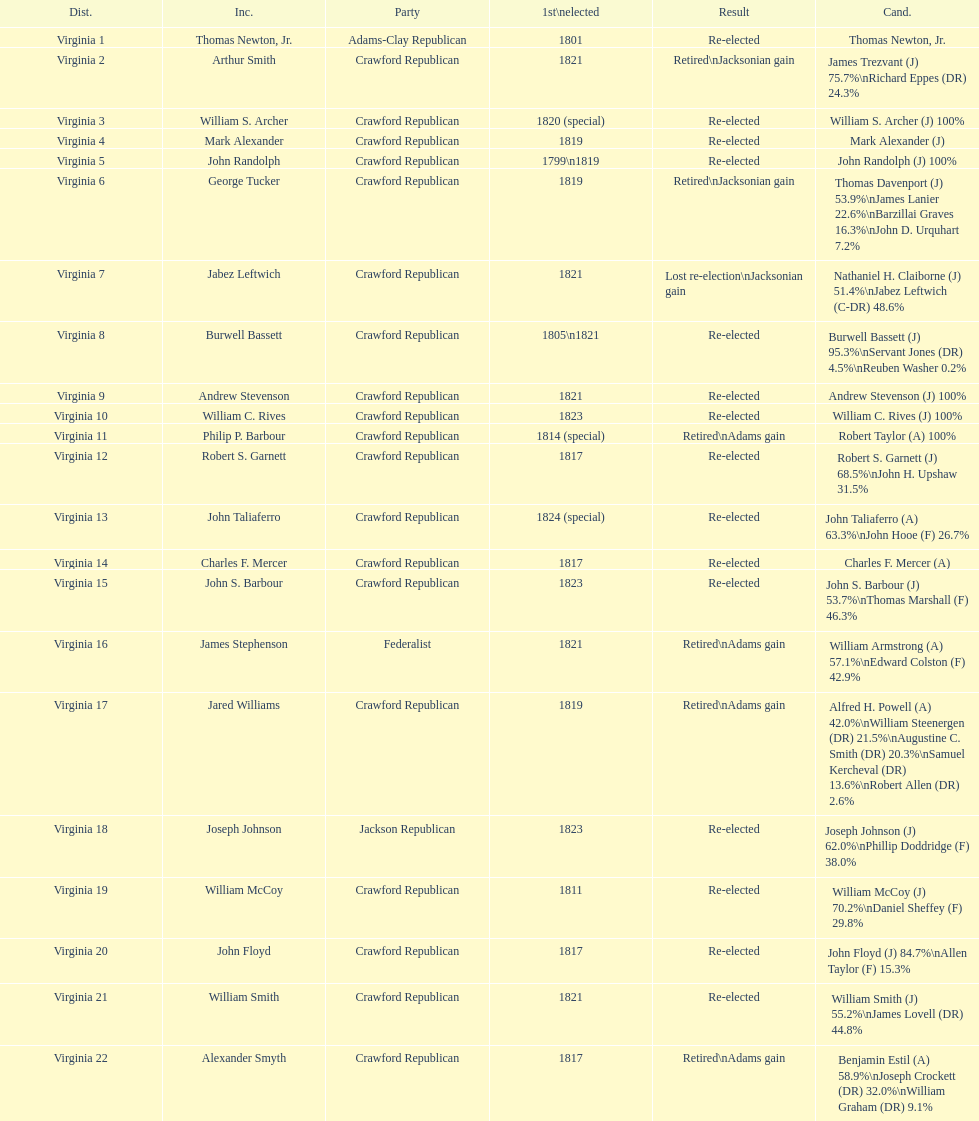Number of incumbents who retired or lost re-election 7. Help me parse the entirety of this table. {'header': ['Dist.', 'Inc.', 'Party', '1st\\nelected', 'Result', 'Cand.'], 'rows': [['Virginia 1', 'Thomas Newton, Jr.', 'Adams-Clay Republican', '1801', 'Re-elected', 'Thomas Newton, Jr.'], ['Virginia 2', 'Arthur Smith', 'Crawford Republican', '1821', 'Retired\\nJacksonian gain', 'James Trezvant (J) 75.7%\\nRichard Eppes (DR) 24.3%'], ['Virginia 3', 'William S. Archer', 'Crawford Republican', '1820 (special)', 'Re-elected', 'William S. Archer (J) 100%'], ['Virginia 4', 'Mark Alexander', 'Crawford Republican', '1819', 'Re-elected', 'Mark Alexander (J)'], ['Virginia 5', 'John Randolph', 'Crawford Republican', '1799\\n1819', 'Re-elected', 'John Randolph (J) 100%'], ['Virginia 6', 'George Tucker', 'Crawford Republican', '1819', 'Retired\\nJacksonian gain', 'Thomas Davenport (J) 53.9%\\nJames Lanier 22.6%\\nBarzillai Graves 16.3%\\nJohn D. Urquhart 7.2%'], ['Virginia 7', 'Jabez Leftwich', 'Crawford Republican', '1821', 'Lost re-election\\nJacksonian gain', 'Nathaniel H. Claiborne (J) 51.4%\\nJabez Leftwich (C-DR) 48.6%'], ['Virginia 8', 'Burwell Bassett', 'Crawford Republican', '1805\\n1821', 'Re-elected', 'Burwell Bassett (J) 95.3%\\nServant Jones (DR) 4.5%\\nReuben Washer 0.2%'], ['Virginia 9', 'Andrew Stevenson', 'Crawford Republican', '1821', 'Re-elected', 'Andrew Stevenson (J) 100%'], ['Virginia 10', 'William C. Rives', 'Crawford Republican', '1823', 'Re-elected', 'William C. Rives (J) 100%'], ['Virginia 11', 'Philip P. Barbour', 'Crawford Republican', '1814 (special)', 'Retired\\nAdams gain', 'Robert Taylor (A) 100%'], ['Virginia 12', 'Robert S. Garnett', 'Crawford Republican', '1817', 'Re-elected', 'Robert S. Garnett (J) 68.5%\\nJohn H. Upshaw 31.5%'], ['Virginia 13', 'John Taliaferro', 'Crawford Republican', '1824 (special)', 'Re-elected', 'John Taliaferro (A) 63.3%\\nJohn Hooe (F) 26.7%'], ['Virginia 14', 'Charles F. Mercer', 'Crawford Republican', '1817', 'Re-elected', 'Charles F. Mercer (A)'], ['Virginia 15', 'John S. Barbour', 'Crawford Republican', '1823', 'Re-elected', 'John S. Barbour (J) 53.7%\\nThomas Marshall (F) 46.3%'], ['Virginia 16', 'James Stephenson', 'Federalist', '1821', 'Retired\\nAdams gain', 'William Armstrong (A) 57.1%\\nEdward Colston (F) 42.9%'], ['Virginia 17', 'Jared Williams', 'Crawford Republican', '1819', 'Retired\\nAdams gain', 'Alfred H. Powell (A) 42.0%\\nWilliam Steenergen (DR) 21.5%\\nAugustine C. Smith (DR) 20.3%\\nSamuel Kercheval (DR) 13.6%\\nRobert Allen (DR) 2.6%'], ['Virginia 18', 'Joseph Johnson', 'Jackson Republican', '1823', 'Re-elected', 'Joseph Johnson (J) 62.0%\\nPhillip Doddridge (F) 38.0%'], ['Virginia 19', 'William McCoy', 'Crawford Republican', '1811', 'Re-elected', 'William McCoy (J) 70.2%\\nDaniel Sheffey (F) 29.8%'], ['Virginia 20', 'John Floyd', 'Crawford Republican', '1817', 'Re-elected', 'John Floyd (J) 84.7%\\nAllen Taylor (F) 15.3%'], ['Virginia 21', 'William Smith', 'Crawford Republican', '1821', 'Re-elected', 'William Smith (J) 55.2%\\nJames Lovell (DR) 44.8%'], ['Virginia 22', 'Alexander Smyth', 'Crawford Republican', '1817', 'Retired\\nAdams gain', 'Benjamin Estil (A) 58.9%\\nJoseph Crockett (DR) 32.0%\\nWilliam Graham (DR) 9.1%']]} 